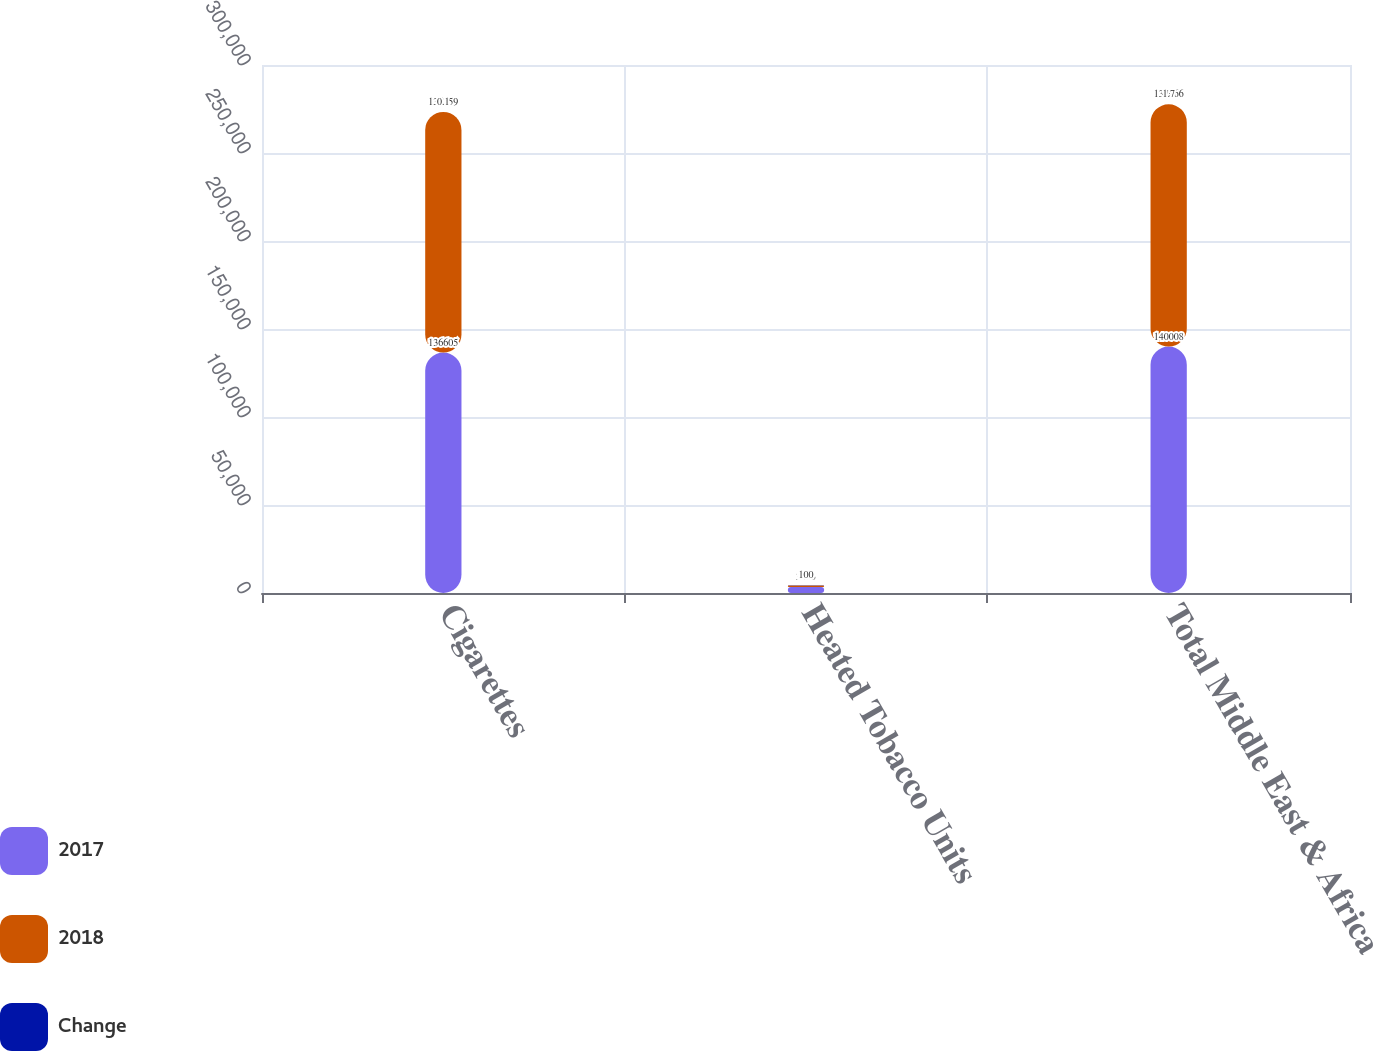Convert chart. <chart><loc_0><loc_0><loc_500><loc_500><stacked_bar_chart><ecel><fcel>Cigarettes<fcel>Heated Tobacco Units<fcel>Total Middle East & Africa<nl><fcel>2017<fcel>136605<fcel>3403<fcel>140008<nl><fcel>2018<fcel>136759<fcel>907<fcel>137666<nl><fcel>Change<fcel>0.1<fcel>100<fcel>1.7<nl></chart> 